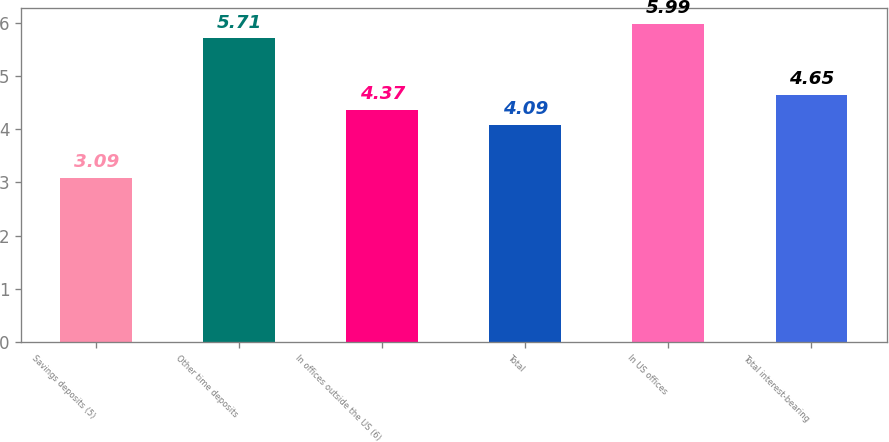Convert chart. <chart><loc_0><loc_0><loc_500><loc_500><bar_chart><fcel>Savings deposits (5)<fcel>Other time deposits<fcel>In offices outside the US (6)<fcel>Total<fcel>In US offices<fcel>Total interest-bearing<nl><fcel>3.09<fcel>5.71<fcel>4.37<fcel>4.09<fcel>5.99<fcel>4.65<nl></chart> 